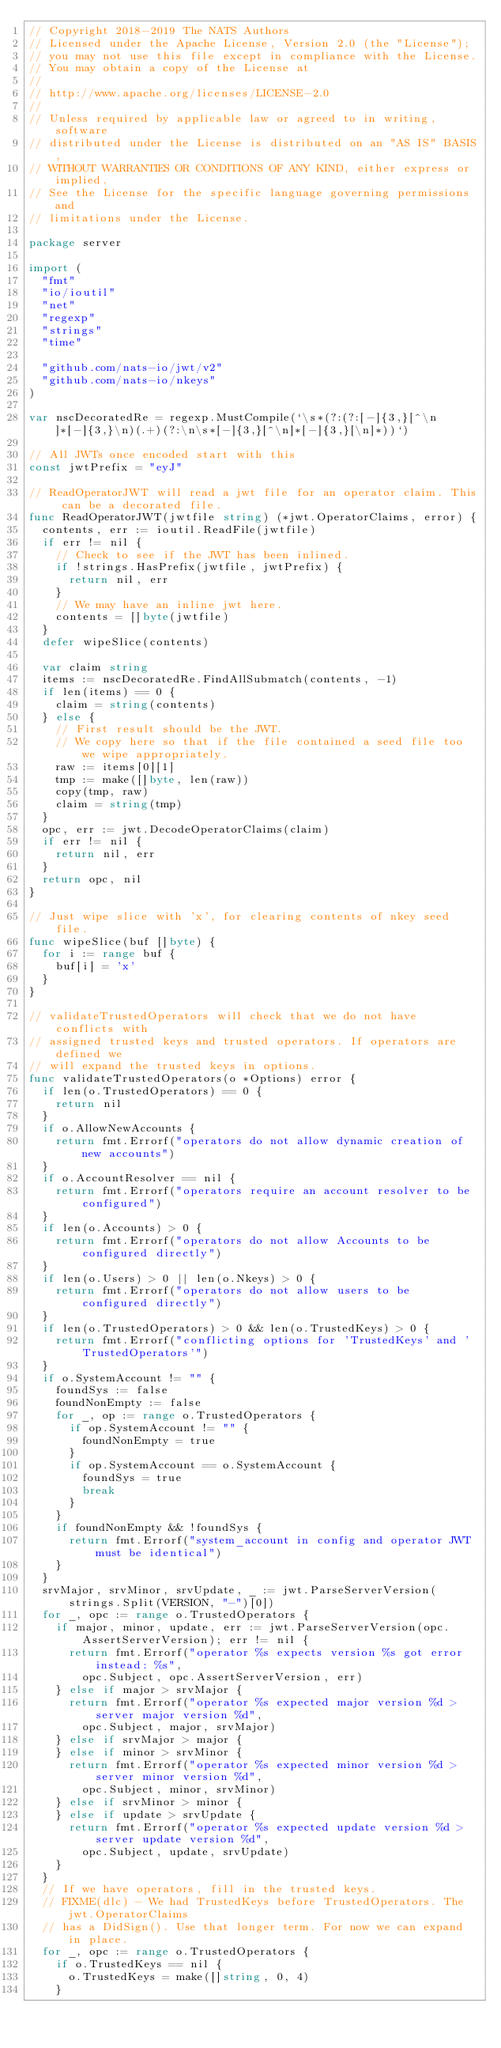Convert code to text. <code><loc_0><loc_0><loc_500><loc_500><_Go_>// Copyright 2018-2019 The NATS Authors
// Licensed under the Apache License, Version 2.0 (the "License");
// you may not use this file except in compliance with the License.
// You may obtain a copy of the License at
//
// http://www.apache.org/licenses/LICENSE-2.0
//
// Unless required by applicable law or agreed to in writing, software
// distributed under the License is distributed on an "AS IS" BASIS,
// WITHOUT WARRANTIES OR CONDITIONS OF ANY KIND, either express or implied.
// See the License for the specific language governing permissions and
// limitations under the License.

package server

import (
	"fmt"
	"io/ioutil"
	"net"
	"regexp"
	"strings"
	"time"

	"github.com/nats-io/jwt/v2"
	"github.com/nats-io/nkeys"
)

var nscDecoratedRe = regexp.MustCompile(`\s*(?:(?:[-]{3,}[^\n]*[-]{3,}\n)(.+)(?:\n\s*[-]{3,}[^\n]*[-]{3,}[\n]*))`)

// All JWTs once encoded start with this
const jwtPrefix = "eyJ"

// ReadOperatorJWT will read a jwt file for an operator claim. This can be a decorated file.
func ReadOperatorJWT(jwtfile string) (*jwt.OperatorClaims, error) {
	contents, err := ioutil.ReadFile(jwtfile)
	if err != nil {
		// Check to see if the JWT has been inlined.
		if !strings.HasPrefix(jwtfile, jwtPrefix) {
			return nil, err
		}
		// We may have an inline jwt here.
		contents = []byte(jwtfile)
	}
	defer wipeSlice(contents)

	var claim string
	items := nscDecoratedRe.FindAllSubmatch(contents, -1)
	if len(items) == 0 {
		claim = string(contents)
	} else {
		// First result should be the JWT.
		// We copy here so that if the file contained a seed file too we wipe appropriately.
		raw := items[0][1]
		tmp := make([]byte, len(raw))
		copy(tmp, raw)
		claim = string(tmp)
	}
	opc, err := jwt.DecodeOperatorClaims(claim)
	if err != nil {
		return nil, err
	}
	return opc, nil
}

// Just wipe slice with 'x', for clearing contents of nkey seed file.
func wipeSlice(buf []byte) {
	for i := range buf {
		buf[i] = 'x'
	}
}

// validateTrustedOperators will check that we do not have conflicts with
// assigned trusted keys and trusted operators. If operators are defined we
// will expand the trusted keys in options.
func validateTrustedOperators(o *Options) error {
	if len(o.TrustedOperators) == 0 {
		return nil
	}
	if o.AllowNewAccounts {
		return fmt.Errorf("operators do not allow dynamic creation of new accounts")
	}
	if o.AccountResolver == nil {
		return fmt.Errorf("operators require an account resolver to be configured")
	}
	if len(o.Accounts) > 0 {
		return fmt.Errorf("operators do not allow Accounts to be configured directly")
	}
	if len(o.Users) > 0 || len(o.Nkeys) > 0 {
		return fmt.Errorf("operators do not allow users to be configured directly")
	}
	if len(o.TrustedOperators) > 0 && len(o.TrustedKeys) > 0 {
		return fmt.Errorf("conflicting options for 'TrustedKeys' and 'TrustedOperators'")
	}
	if o.SystemAccount != "" {
		foundSys := false
		foundNonEmpty := false
		for _, op := range o.TrustedOperators {
			if op.SystemAccount != "" {
				foundNonEmpty = true
			}
			if op.SystemAccount == o.SystemAccount {
				foundSys = true
				break
			}
		}
		if foundNonEmpty && !foundSys {
			return fmt.Errorf("system_account in config and operator JWT must be identical")
		}
	}
	srvMajor, srvMinor, srvUpdate, _ := jwt.ParseServerVersion(strings.Split(VERSION, "-")[0])
	for _, opc := range o.TrustedOperators {
		if major, minor, update, err := jwt.ParseServerVersion(opc.AssertServerVersion); err != nil {
			return fmt.Errorf("operator %s expects version %s got error instead: %s",
				opc.Subject, opc.AssertServerVersion, err)
		} else if major > srvMajor {
			return fmt.Errorf("operator %s expected major version %d > server major version %d",
				opc.Subject, major, srvMajor)
		} else if srvMajor > major {
		} else if minor > srvMinor {
			return fmt.Errorf("operator %s expected minor version %d > server minor version %d",
				opc.Subject, minor, srvMinor)
		} else if srvMinor > minor {
		} else if update > srvUpdate {
			return fmt.Errorf("operator %s expected update version %d > server update version %d",
				opc.Subject, update, srvUpdate)
		}
	}
	// If we have operators, fill in the trusted keys.
	// FIXME(dlc) - We had TrustedKeys before TrustedOperators. The jwt.OperatorClaims
	// has a DidSign(). Use that longer term. For now we can expand in place.
	for _, opc := range o.TrustedOperators {
		if o.TrustedKeys == nil {
			o.TrustedKeys = make([]string, 0, 4)
		}</code> 